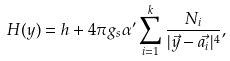Convert formula to latex. <formula><loc_0><loc_0><loc_500><loc_500>H ( y ) = h + 4 \pi g _ { s } \alpha ^ { \prime } \sum _ { i = 1 } ^ { k } \frac { N _ { i } } { | \vec { y } - \vec { a _ { i } } | ^ { 4 } } ,</formula> 